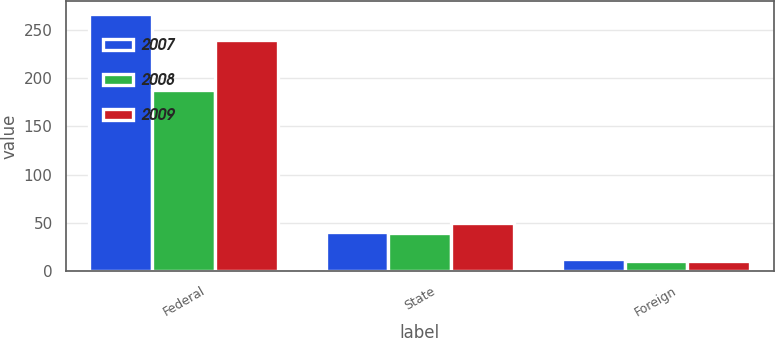<chart> <loc_0><loc_0><loc_500><loc_500><stacked_bar_chart><ecel><fcel>Federal<fcel>State<fcel>Foreign<nl><fcel>2007<fcel>266.2<fcel>41<fcel>12.2<nl><fcel>2008<fcel>188.1<fcel>39.8<fcel>10.4<nl><fcel>2009<fcel>238.9<fcel>49.9<fcel>10.2<nl></chart> 